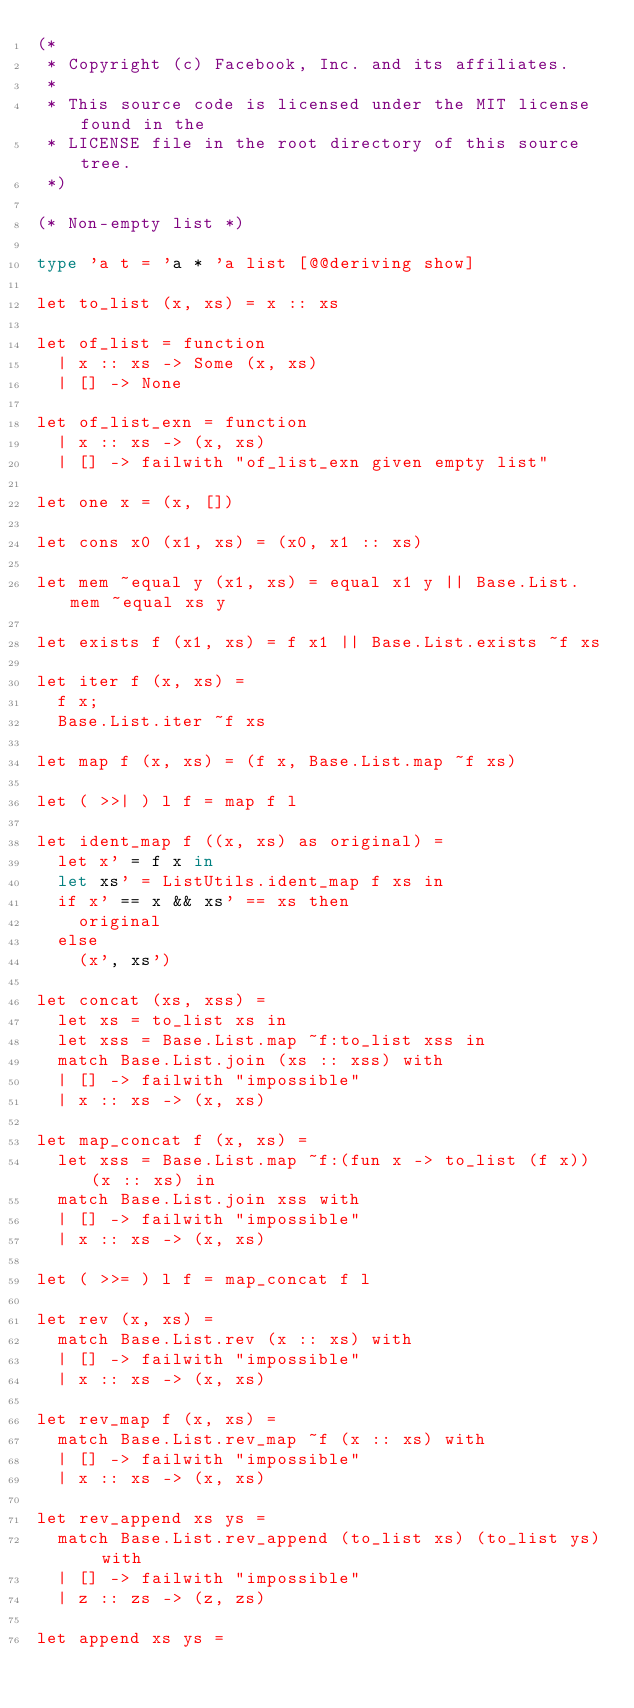<code> <loc_0><loc_0><loc_500><loc_500><_OCaml_>(*
 * Copyright (c) Facebook, Inc. and its affiliates.
 *
 * This source code is licensed under the MIT license found in the
 * LICENSE file in the root directory of this source tree.
 *)

(* Non-empty list *)

type 'a t = 'a * 'a list [@@deriving show]

let to_list (x, xs) = x :: xs

let of_list = function
  | x :: xs -> Some (x, xs)
  | [] -> None

let of_list_exn = function
  | x :: xs -> (x, xs)
  | [] -> failwith "of_list_exn given empty list"

let one x = (x, [])

let cons x0 (x1, xs) = (x0, x1 :: xs)

let mem ~equal y (x1, xs) = equal x1 y || Base.List.mem ~equal xs y

let exists f (x1, xs) = f x1 || Base.List.exists ~f xs

let iter f (x, xs) =
  f x;
  Base.List.iter ~f xs

let map f (x, xs) = (f x, Base.List.map ~f xs)

let ( >>| ) l f = map f l

let ident_map f ((x, xs) as original) =
  let x' = f x in
  let xs' = ListUtils.ident_map f xs in
  if x' == x && xs' == xs then
    original
  else
    (x', xs')

let concat (xs, xss) =
  let xs = to_list xs in
  let xss = Base.List.map ~f:to_list xss in
  match Base.List.join (xs :: xss) with
  | [] -> failwith "impossible"
  | x :: xs -> (x, xs)

let map_concat f (x, xs) =
  let xss = Base.List.map ~f:(fun x -> to_list (f x)) (x :: xs) in
  match Base.List.join xss with
  | [] -> failwith "impossible"
  | x :: xs -> (x, xs)

let ( >>= ) l f = map_concat f l

let rev (x, xs) =
  match Base.List.rev (x :: xs) with
  | [] -> failwith "impossible"
  | x :: xs -> (x, xs)

let rev_map f (x, xs) =
  match Base.List.rev_map ~f (x :: xs) with
  | [] -> failwith "impossible"
  | x :: xs -> (x, xs)

let rev_append xs ys =
  match Base.List.rev_append (to_list xs) (to_list ys) with
  | [] -> failwith "impossible"
  | z :: zs -> (z, zs)

let append xs ys =</code> 